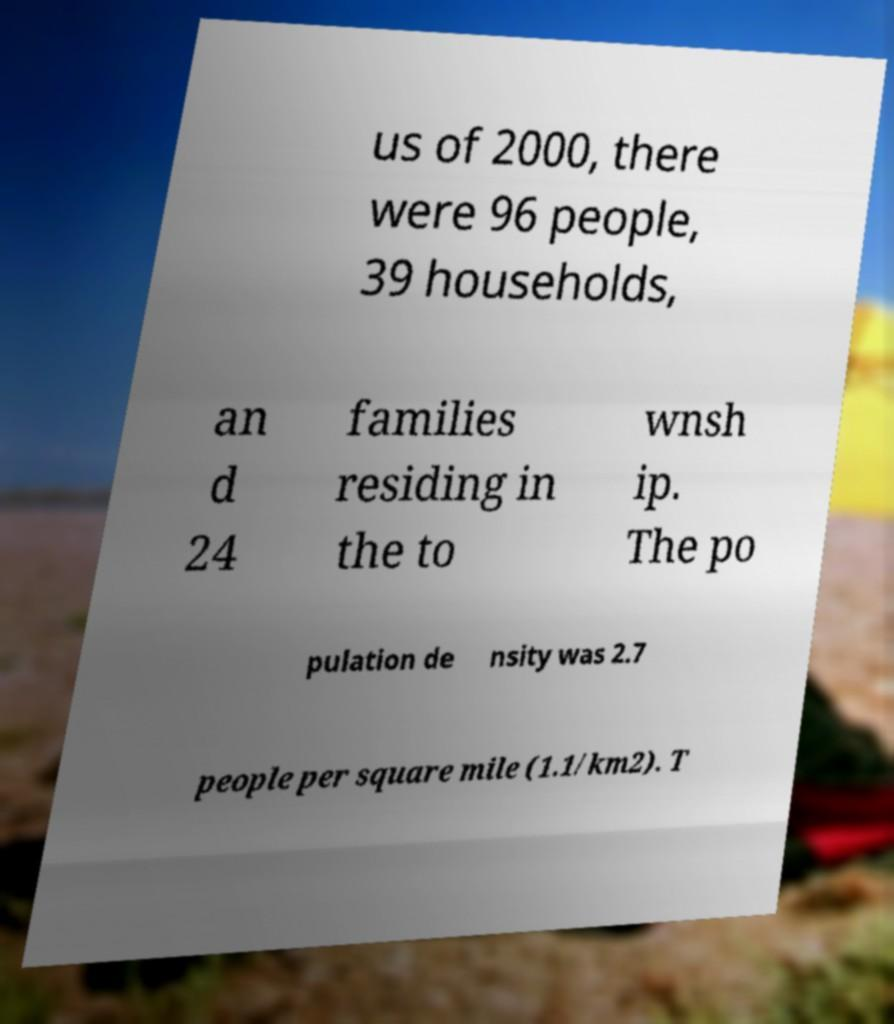Could you assist in decoding the text presented in this image and type it out clearly? us of 2000, there were 96 people, 39 households, an d 24 families residing in the to wnsh ip. The po pulation de nsity was 2.7 people per square mile (1.1/km2). T 